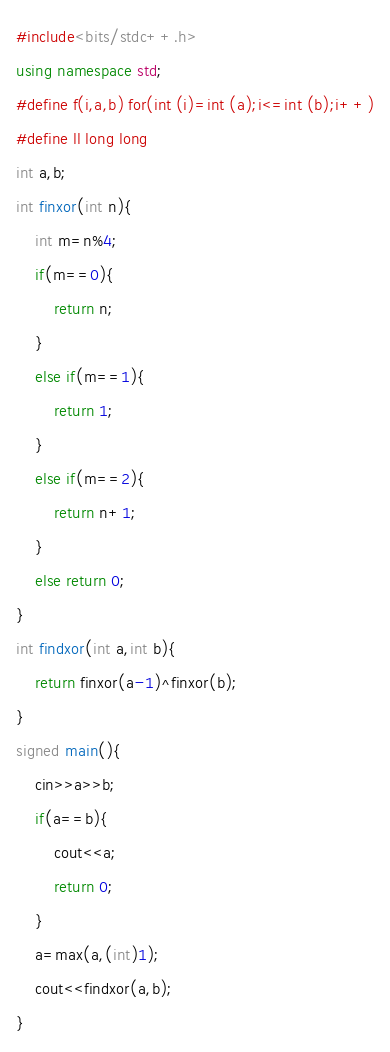<code> <loc_0><loc_0><loc_500><loc_500><_C++_>#include<bits/stdc++.h>
using namespace std;
#define f(i,a,b) for(int (i)=int (a);i<=int (b);i++)
#define ll long long
int a,b;
int finxor(int n){
	int m=n%4;
	if(m==0){
		return n;
	}
	else if(m==1){
		return 1;
	}
	else if(m==2){
		return n+1;
	}
	else return 0;
}
int findxor(int a,int b){
	return finxor(a-1)^finxor(b);
}
signed main(){
	cin>>a>>b;
	if(a==b){
		cout<<a;
		return 0;
	}
	a=max(a,(int)1);
	cout<<findxor(a,b);
}
</code> 